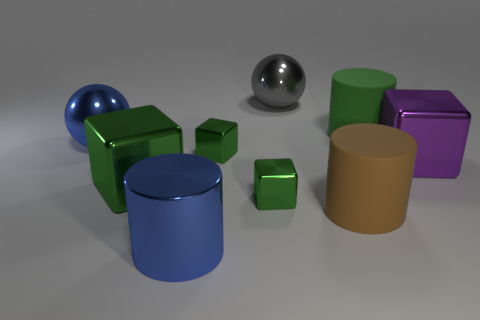The big metallic cylinder has what color?
Your answer should be very brief. Blue. Is the number of large shiny blocks left of the big blue cylinder less than the number of large purple shiny cubes?
Make the answer very short. No. Is there any other thing that is the same shape as the brown object?
Your answer should be compact. Yes. Are any green rubber things visible?
Keep it short and to the point. Yes. Are there fewer blue metal objects than gray metal balls?
Your answer should be compact. No. What number of big purple cubes have the same material as the big blue cylinder?
Make the answer very short. 1. There is a cylinder that is made of the same material as the large gray thing; what is its color?
Keep it short and to the point. Blue. The green matte thing has what shape?
Ensure brevity in your answer.  Cylinder. What number of big blocks have the same color as the large metallic cylinder?
Offer a terse response. 0. What shape is the purple metallic thing that is the same size as the brown matte object?
Provide a short and direct response. Cube. 